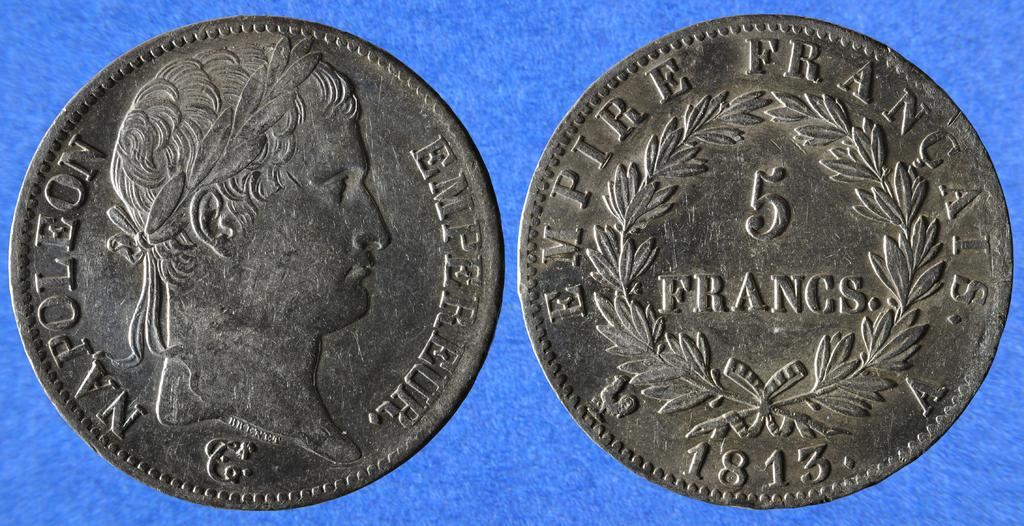<image>
Describe the image concisely. Two coins side by side with one coin saying Napoleon on the front. 